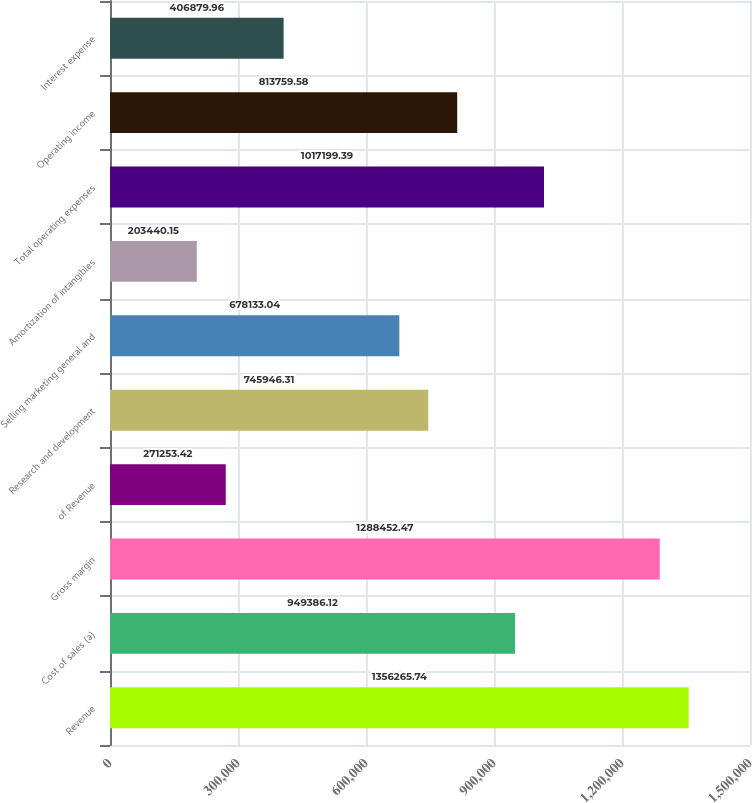Convert chart to OTSL. <chart><loc_0><loc_0><loc_500><loc_500><bar_chart><fcel>Revenue<fcel>Cost of sales (a)<fcel>Gross margin<fcel>of Revenue<fcel>Research and development<fcel>Selling marketing general and<fcel>Amortization of intangibles<fcel>Total operating expenses<fcel>Operating income<fcel>Interest expense<nl><fcel>1.35627e+06<fcel>949386<fcel>1.28845e+06<fcel>271253<fcel>745946<fcel>678133<fcel>203440<fcel>1.0172e+06<fcel>813760<fcel>406880<nl></chart> 